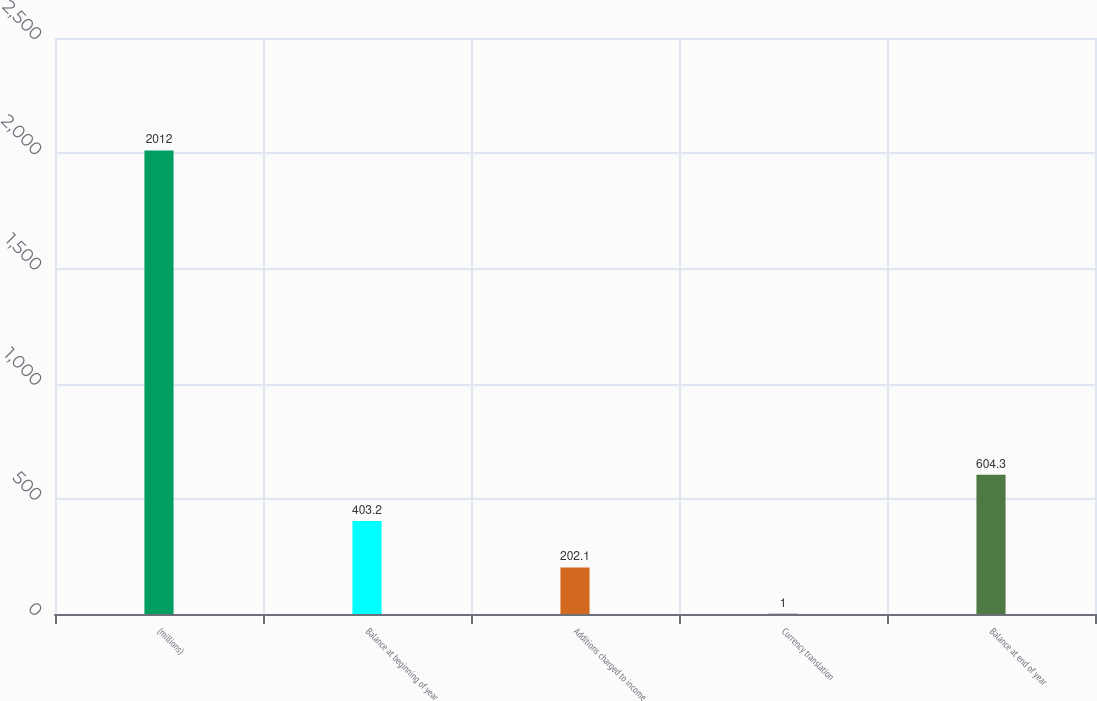<chart> <loc_0><loc_0><loc_500><loc_500><bar_chart><fcel>(millions)<fcel>Balance at beginning of year<fcel>Additions charged to income<fcel>Currency translation<fcel>Balance at end of year<nl><fcel>2012<fcel>403.2<fcel>202.1<fcel>1<fcel>604.3<nl></chart> 